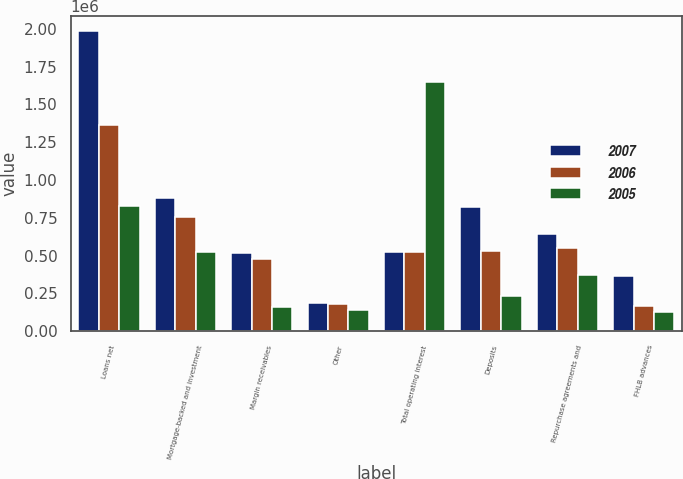Convert chart. <chart><loc_0><loc_0><loc_500><loc_500><stacked_bar_chart><ecel><fcel>Loans net<fcel>Mortgage-backed and investment<fcel>Margin receivables<fcel>Other<fcel>Total operating interest<fcel>Deposits<fcel>Repurchase agreements and<fcel>FHLB advances<nl><fcel>2007<fcel>1.98603e+06<fcel>880217<fcel>519099<fcel>184361<fcel>521671<fcel>821955<fcel>643382<fcel>364442<nl><fcel>2006<fcel>1.36487e+06<fcel>754340<fcel>474500<fcel>180966<fcel>521671<fcel>531217<fcel>549085<fcel>165545<nl><fcel>2005<fcel>828717<fcel>524243<fcel>159442<fcel>137862<fcel>1.65026e+06<fcel>232312<fcel>374337<fcel>126495<nl></chart> 